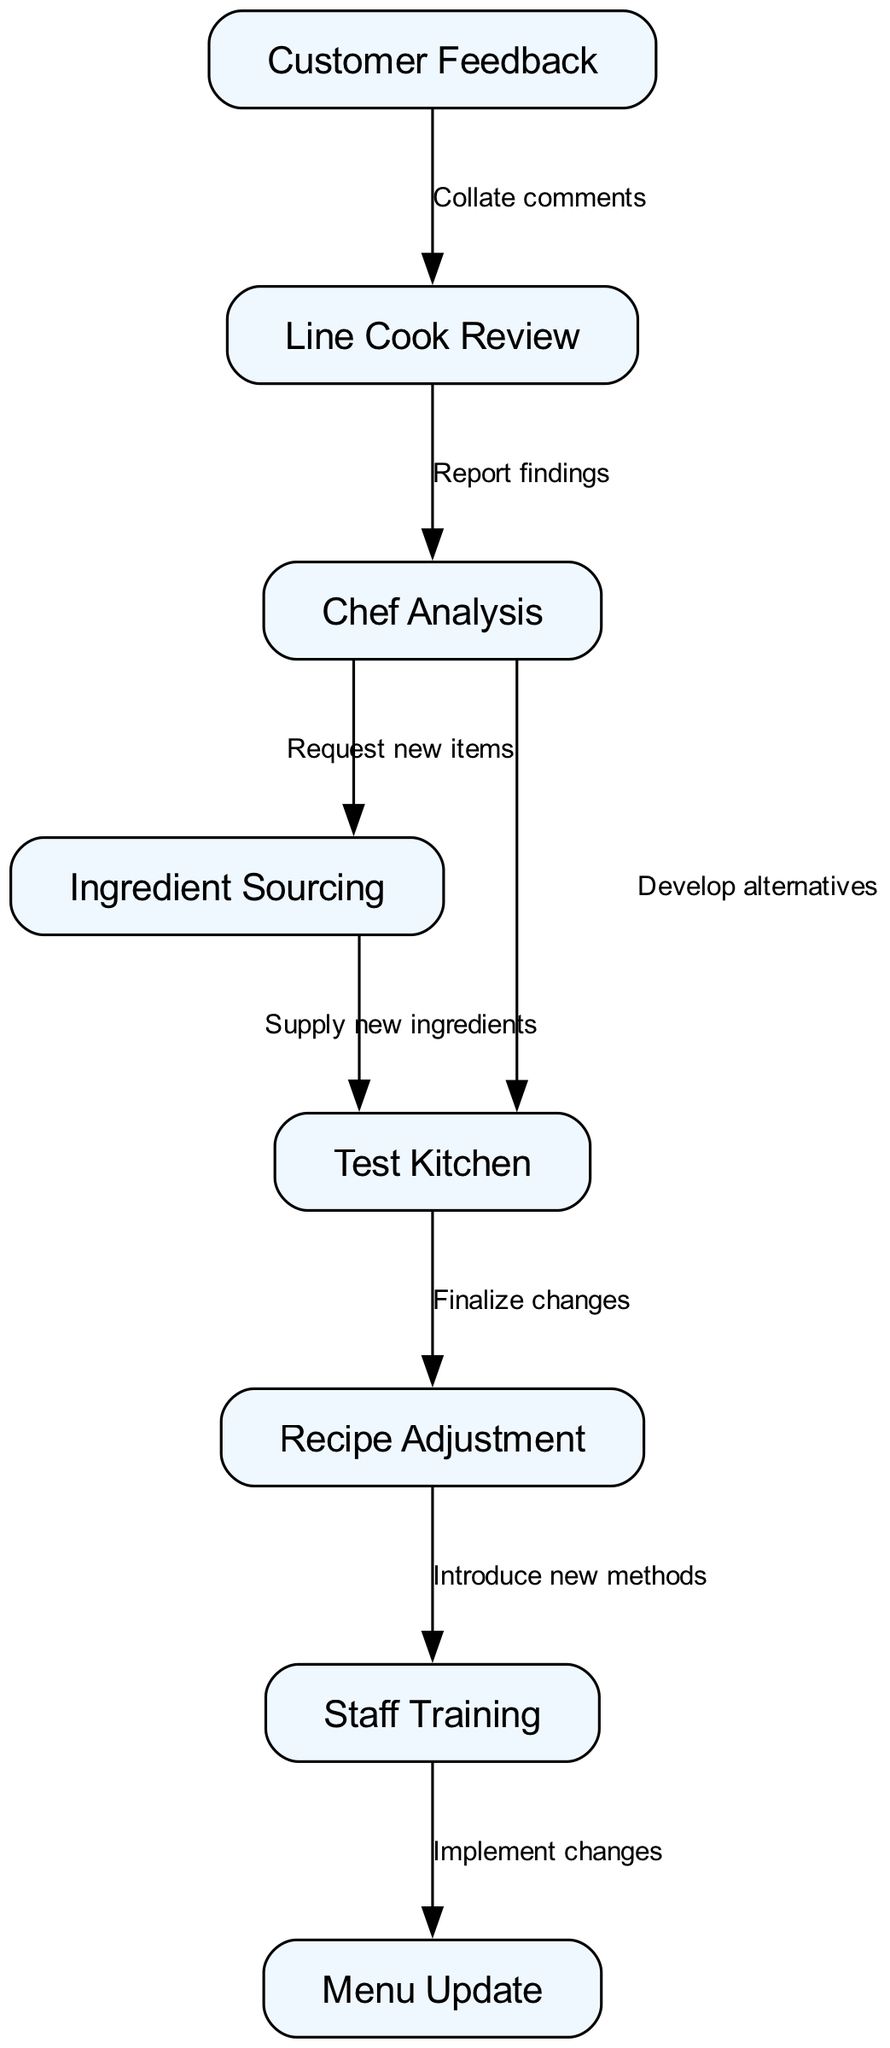What's the total number of nodes in the diagram? The diagram lists 8 distinct nodes, including "Customer Feedback," "Line Cook Review," "Chef Analysis," "Ingredient Sourcing," "Test Kitchen," "Recipe Adjustment," "Staff Training," and "Menu Update." Counting each of these gives a total of 8 nodes.
Answer: 8 What is the first step in the recipe modification process? The first node in the directed graph is "Customer Feedback," which indicates that it is the first step in the modification process, as all other steps follow from it.
Answer: Customer Feedback Which nodes are directly connected to the "Chef Analysis" node? The "Chef Analysis" node has two outgoing edges to "Ingredient Sourcing" and "Test Kitchen." This means that it is directly connected to both of these nodes.
Answer: Ingredient Sourcing, Test Kitchen What is the outcome of the Test Kitchen step? The output of the "Test Kitchen" step is "Recipe Adjustment," which indicates that after testing, changes to the recipe are finalized.
Answer: Recipe Adjustment How many edges are there in total in the diagram? By counting all the connections (edges) that go from one node to another, we find there are a total of 8 edges. Each edge connects two nodes in the directed graph, indicating a flow of actions.
Answer: 8 Which step comes immediately after "Staff Training"? The node that comes immediately after "Staff Training" is "Menu Update," indicating that after staff training, the changes are implemented into the menu.
Answer: Menu Update What does the "Line Cook Review" accomplish in the process? The "Line Cook Review" step has the function of reporting findings, as indicated by its directed edge to "Chef Analysis." This step helps in summarizing feedback before further analyses are conducted.
Answer: Report findings What activity occurs between "Ingredient Sourcing" and "Test Kitchen"? The activity that occurs is the supply of new ingredients, indicated by the directed edge between the two nodes. The "Ingredient Sourcing" node leads directly to the "Test Kitchen," meaning new ingredients are provided for testing.
Answer: Supply new ingredients 